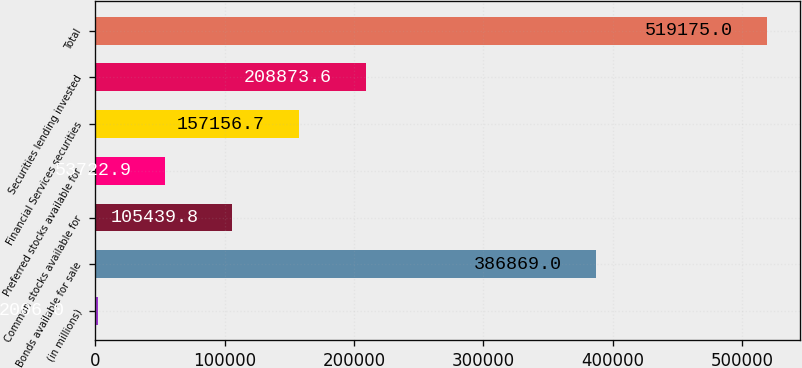Convert chart. <chart><loc_0><loc_0><loc_500><loc_500><bar_chart><fcel>(in millions)<fcel>Bonds available for sale<fcel>Common stocks available for<fcel>Preferred stocks available for<fcel>Financial Services securities<fcel>Securities lending invested<fcel>Total<nl><fcel>2006<fcel>386869<fcel>105440<fcel>53722.9<fcel>157157<fcel>208874<fcel>519175<nl></chart> 